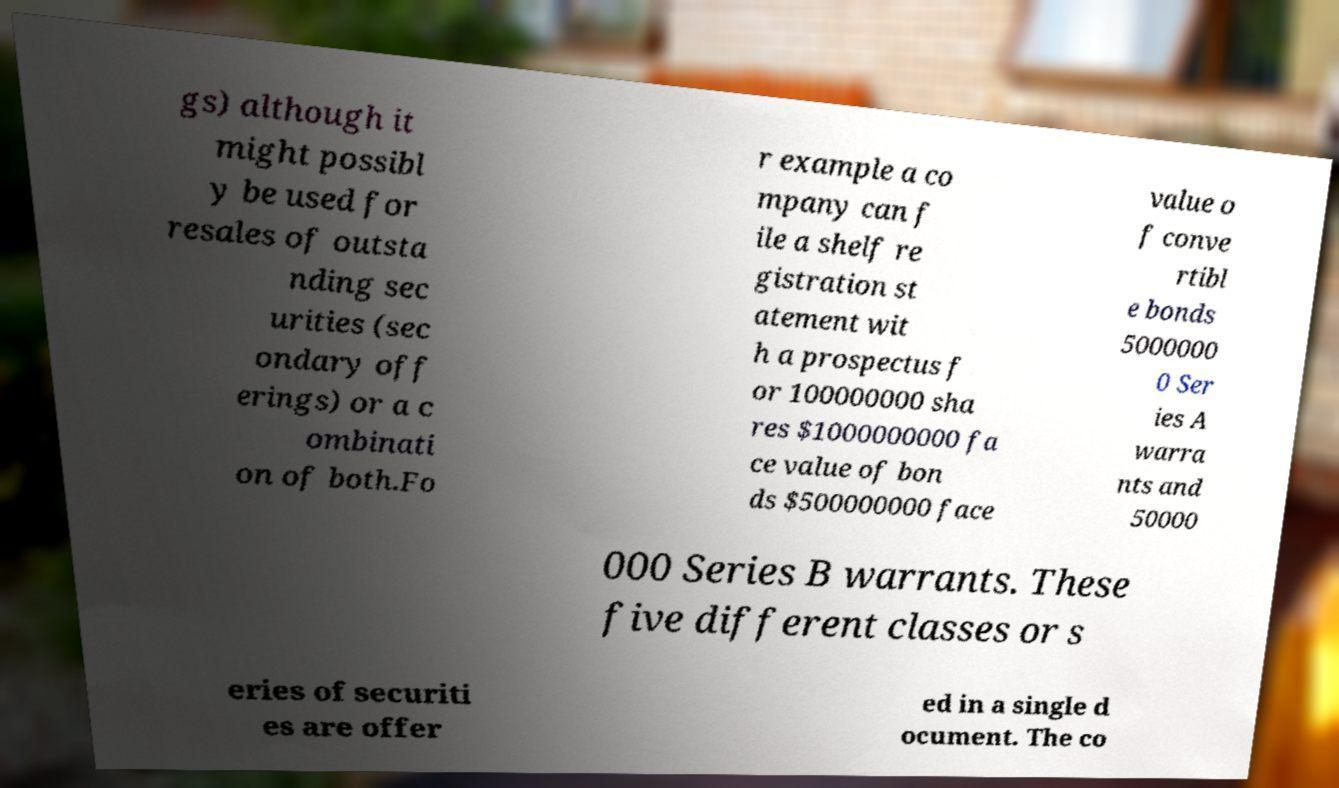There's text embedded in this image that I need extracted. Can you transcribe it verbatim? gs) although it might possibl y be used for resales of outsta nding sec urities (sec ondary off erings) or a c ombinati on of both.Fo r example a co mpany can f ile a shelf re gistration st atement wit h a prospectus f or 100000000 sha res $1000000000 fa ce value of bon ds $500000000 face value o f conve rtibl e bonds 5000000 0 Ser ies A warra nts and 50000 000 Series B warrants. These five different classes or s eries of securiti es are offer ed in a single d ocument. The co 